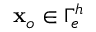<formula> <loc_0><loc_0><loc_500><loc_500>{ x } _ { o } \in \Gamma _ { e } ^ { h }</formula> 